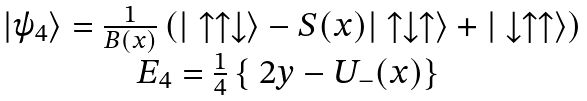<formula> <loc_0><loc_0><loc_500><loc_500>\begin{array} { c } | \psi _ { 4 } \rangle = \frac { 1 } { B ( x ) } \left ( | \uparrow \uparrow \downarrow \rangle - S ( x ) | \uparrow \downarrow \uparrow \rangle + | \downarrow \uparrow \uparrow \rangle \right ) \\ E _ { 4 } = \frac { 1 } { 4 } \left \{ \ 2 y - U _ { - } ( x ) \right \} \ \end{array}</formula> 